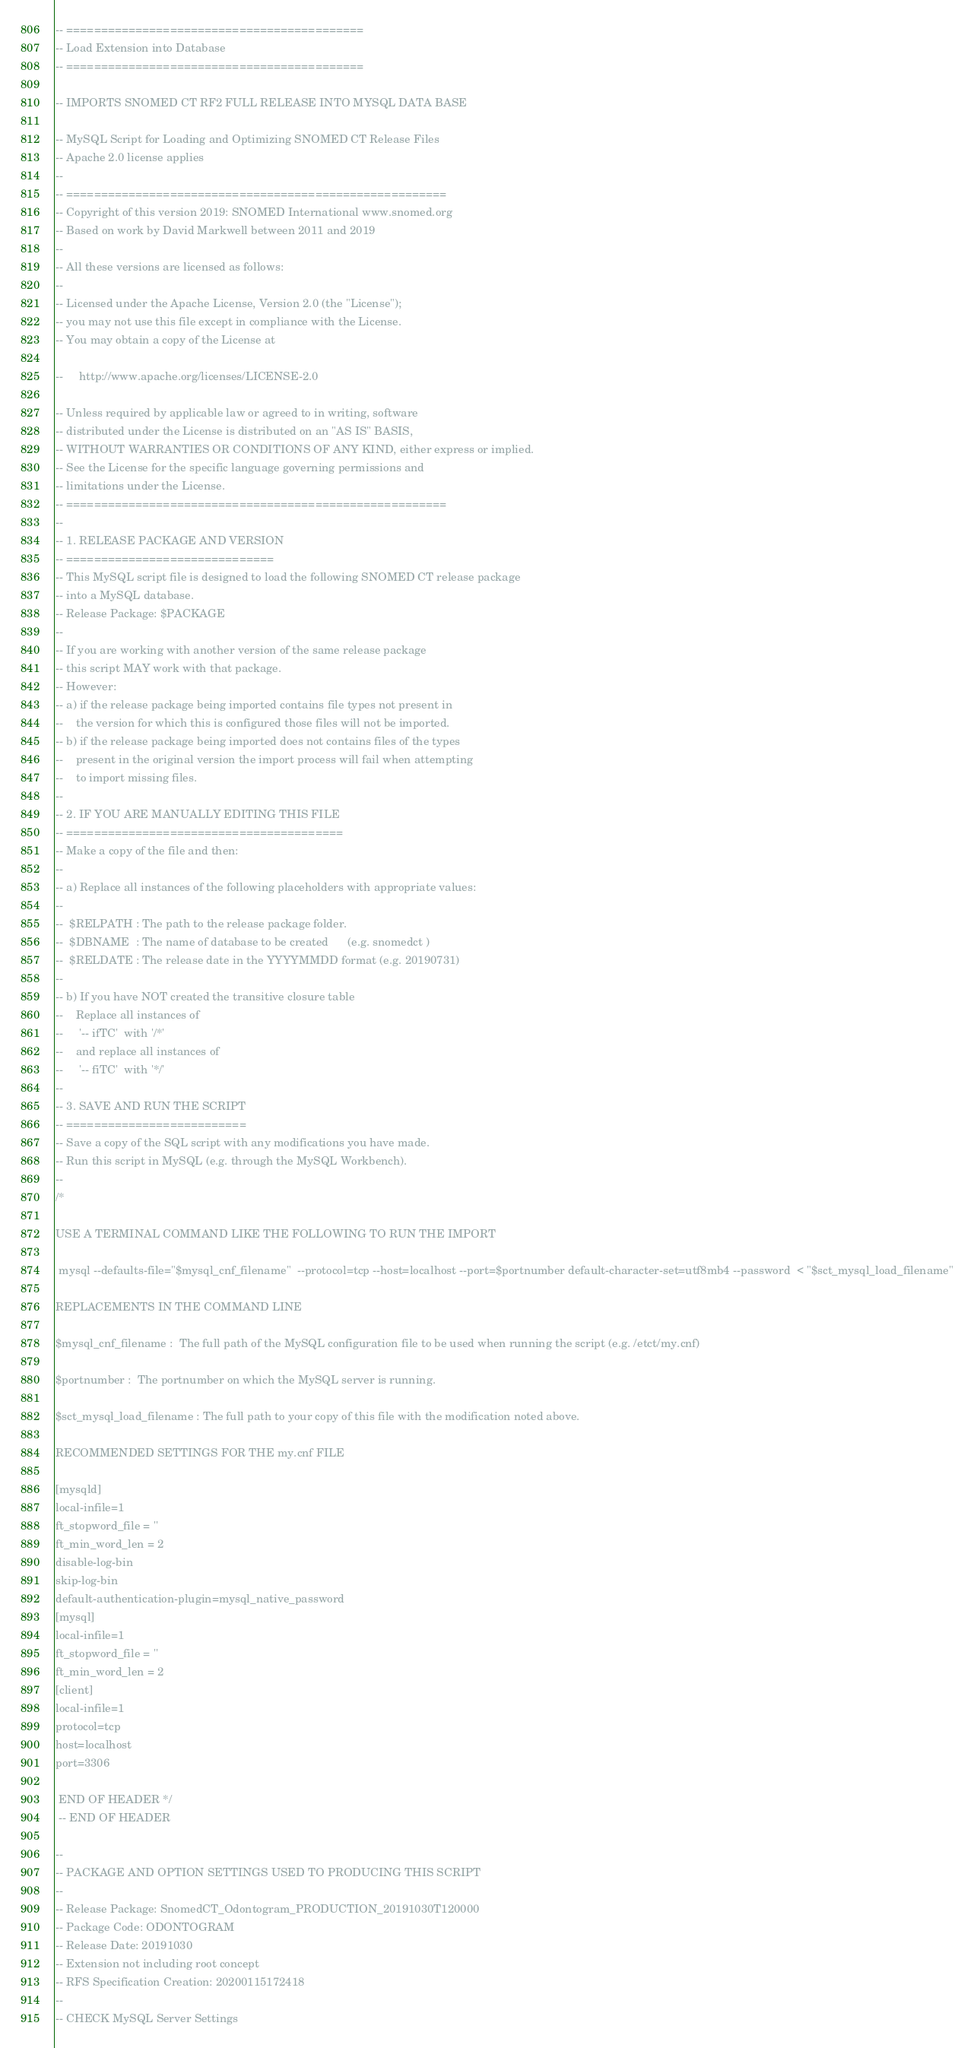<code> <loc_0><loc_0><loc_500><loc_500><_SQL_>

-- ===========================================
-- Load Extension into Database
-- ===========================================

-- IMPORTS SNOMED CT RF2 FULL RELEASE INTO MYSQL DATA BASE

-- MySQL Script for Loading and Optimizing SNOMED CT Release Files
-- Apache 2.0 license applies
-- 
-- =======================================================
-- Copyright of this version 2019: SNOMED International www.snomed.org
-- Based on work by David Markwell between 2011 and 2019
-- 
-- All these versions are licensed as follows:
--
-- Licensed under the Apache License, Version 2.0 (the "License");
-- you may not use this file except in compliance with the License.
-- You may obtain a copy of the License at

--     http://www.apache.org/licenses/LICENSE-2.0

-- Unless required by applicable law or agreed to in writing, software
-- distributed under the License is distributed on an "AS IS" BASIS,
-- WITHOUT WARRANTIES OR CONDITIONS OF ANY KIND, either express or implied.
-- See the License for the specific language governing permissions and
-- limitations under the License.
-- =======================================================
--
-- 1. RELEASE PACKAGE AND VERSION 
-- ==============================
-- This MySQL script file is designed to load the following SNOMED CT release package
-- into a MySQL database.
-- Release Package: $PACKAGE 
--
-- If you are working with another version of the same release package
-- this script MAY work with that package. 
-- However:
-- a) if the release package being imported contains file types not present in
--    the version for which this is configured those files will not be imported.
-- b) if the release package being imported does not contains files of the types
--    present in the original version the import process will fail when attempting
--    to import missing files.
-- 
-- 2. IF YOU ARE MANUALLY EDITING THIS FILE
-- ========================================
-- Make a copy of the file and then:
-- 
-- a) Replace all instances of the following placeholders with appropriate values:
--
--  $RELPATH : The path to the release package folder.
--  $DBNAME  : The name of database to be created      (e.g. snomedct )
--  $RELDATE : The release date in the YYYYMMDD format (e.g. 20190731)
--
-- b) If you have NOT created the transitive closure table
--    Replace all instances of 
--     '-- ifTC'  with '/*'
--    and replace all instances of 
--     '-- fiTC'  with '*/'
--
-- 3. SAVE AND RUN THE SCRIPT
-- ==========================
-- Save a copy of the SQL script with any modifications you have made.
-- Run this script in MySQL (e.g. through the MySQL Workbench).
--
/*

USE A TERMINAL COMMAND LIKE THE FOLLOWING TO RUN THE IMPORT

 mysql --defaults-file="$mysql_cnf_filename"  --protocol=tcp --host=localhost --port=$portnumber default-character-set=utf8mb4 --password  < "$sct_mysql_load_filename"

REPLACEMENTS IN THE COMMAND LINE

$mysql_cnf_filename :  The full path of the MySQL configuration file to be used when running the script (e.g. /etct/my.cnf)

$portnumber :  The portnumber on which the MySQL server is running.

$sct_mysql_load_filename : The full path to your copy of this file with the modification noted above.

RECOMMENDED SETTINGS FOR THE my.cnf FILE

[mysqld]
local-infile=1
ft_stopword_file = ''
ft_min_word_len = 2
disable-log-bin
skip-log-bin
default-authentication-plugin=mysql_native_password
[mysql]
local-infile=1
ft_stopword_file = '' 
ft_min_word_len = 2
[client]
local-infile=1
protocol=tcp
host=localhost
port=3306

 END OF HEADER */
 -- END OF HEADER

-- 
-- PACKAGE AND OPTION SETTINGS USED TO PRODUCING THIS SCRIPT
-- 
-- Release Package: SnomedCT_Odontogram_PRODUCTION_20191030T120000
-- Package Code: ODONTOGRAM
-- Release Date: 20191030
-- Extension not including root concept
-- RFS Specification Creation: 20200115172418
-- 
-- CHECK MySQL Server Settings
</code> 